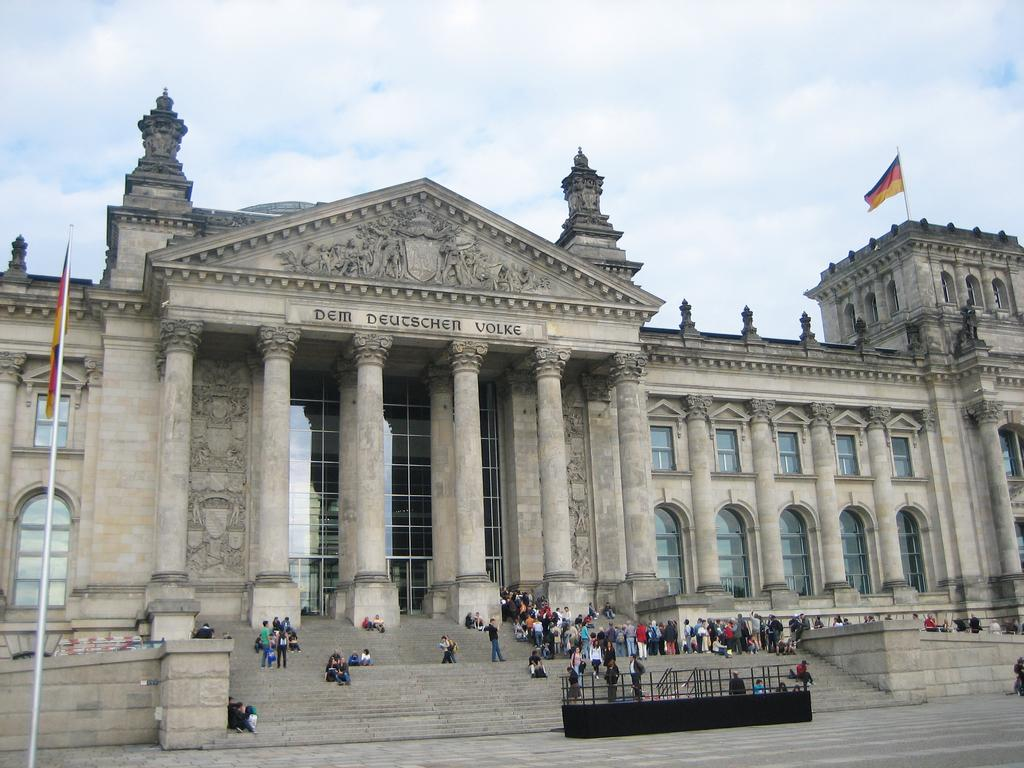What type of structure is present in the image? There is a building in the image. What feature of the building is mentioned in the facts? The building has many windows. Are there any other objects or features in the image related to the building? Yes, there are two flags and staircases in the image. How would you describe the weather based on the image? The sky is cloudy in the image. Can you see any snakes slithering around the building in the image? No, there are no snakes present in the image. Is there an ocean visible in the image? No, there is no ocean visible in the image. 